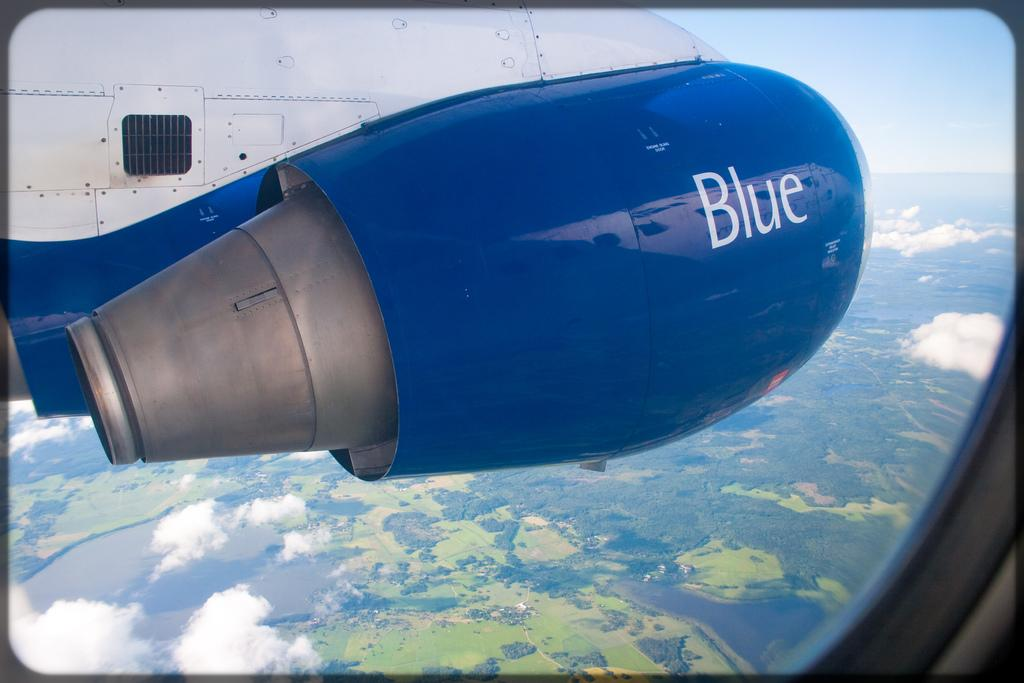<image>
Give a short and clear explanation of the subsequent image. a jet engine with the word BLUE outside an airplane window 